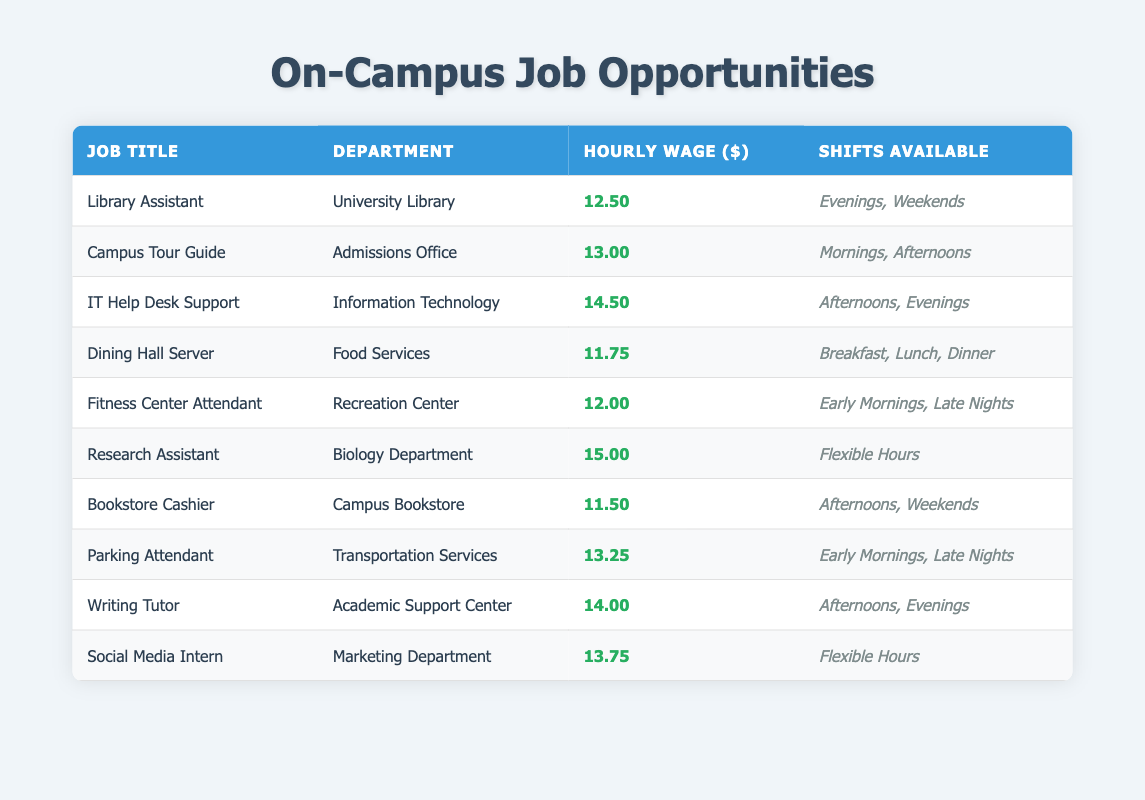What is the highest-paying job listed in the table? The job with the highest hourly wage can be found by comparing the values in the "Hourly Wage ($)" column. The highest value is 15.00 for the "Research Assistant" position.
Answer: Research Assistant Which department employs a Library Assistant? Looking at the "Department" column for the "Library Assistant" job title, we can see that it is listed under "University Library."
Answer: University Library How many jobs offer flexible hours? The table indicates that "Research Assistant" and "Social Media Intern" both have "Flexible Hours" listed in the "Shifts Available" column. Therefore, there are 2 jobs offering flexible hours.
Answer: 2 Are there any jobs available during evenings? Yes, upon reviewing the "Shifts Available" column, we find multiple jobs like "Library Assistant," "IT Help Desk Support," "Writing Tutor," and "Social Media Intern" that mention evenings as part of their shifts.
Answer: Yes What is the average hourly wage of all jobs listed? To calculate the average, add all the hourly wages: (12.50 + 13.00 + 14.50 + 11.75 + 12.00 + 15.00 + 11.50 + 13.25 + 14.00 + 13.75) =  131.25. Then divide that by the total number of jobs (10), resulting in an average of 13.125.
Answer: 13.13 Which job title has the lowest hourly wage? By examining the "Hourly Wage ($)" column, we see that the lowest value is 11.50, which corresponds to the "Bookstore Cashier" position.
Answer: Bookstore Cashier Is there a parking attendant job available? Yes, the table includes a "Parking Attendant" job in the "Transportation Services" department with specified shifts.
Answer: Yes How many jobs are offered in the afternoons? By inspecting the "Shifts Available" column, we can see that "Campus Tour Guide," "IT Help Desk Support," "Bookstore Cashier," and "Writing Tutor" all mention afternoons as available shifts. This totals 4 jobs available in the afternoons.
Answer: 4 